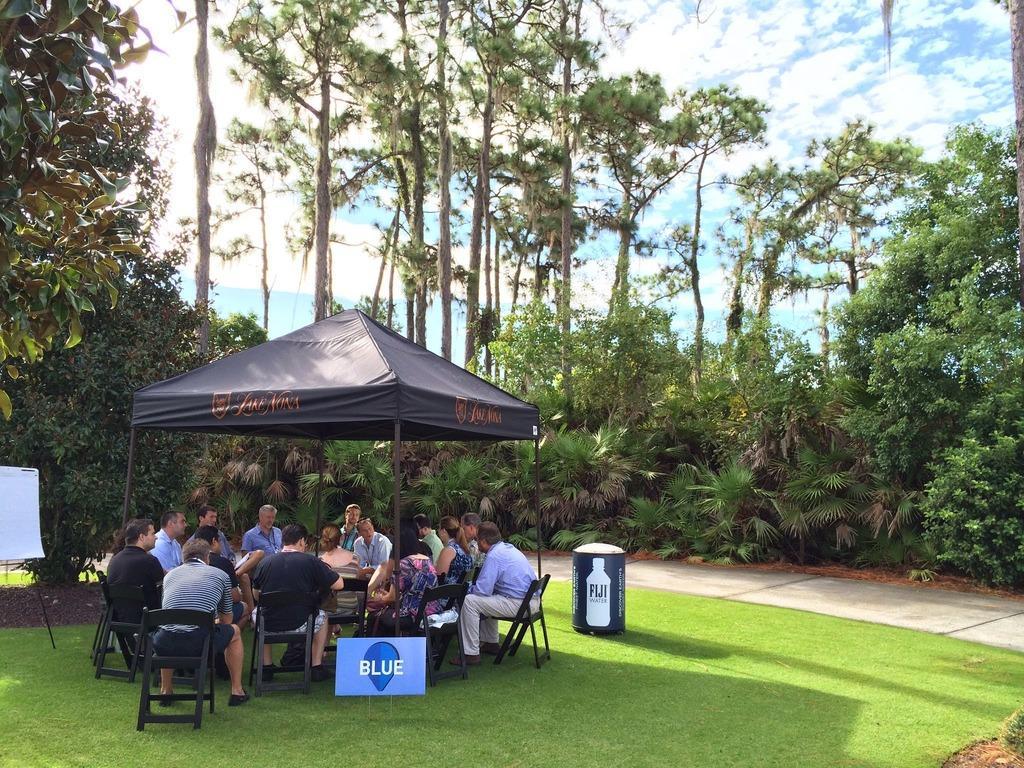Please provide a concise description of this image. In this picture we can see a group of people sitting on chairs and beside them we can see a board, tin, name board and these group of people are under a tent and in the background we can see trees, path, grass, sky with clouds. 